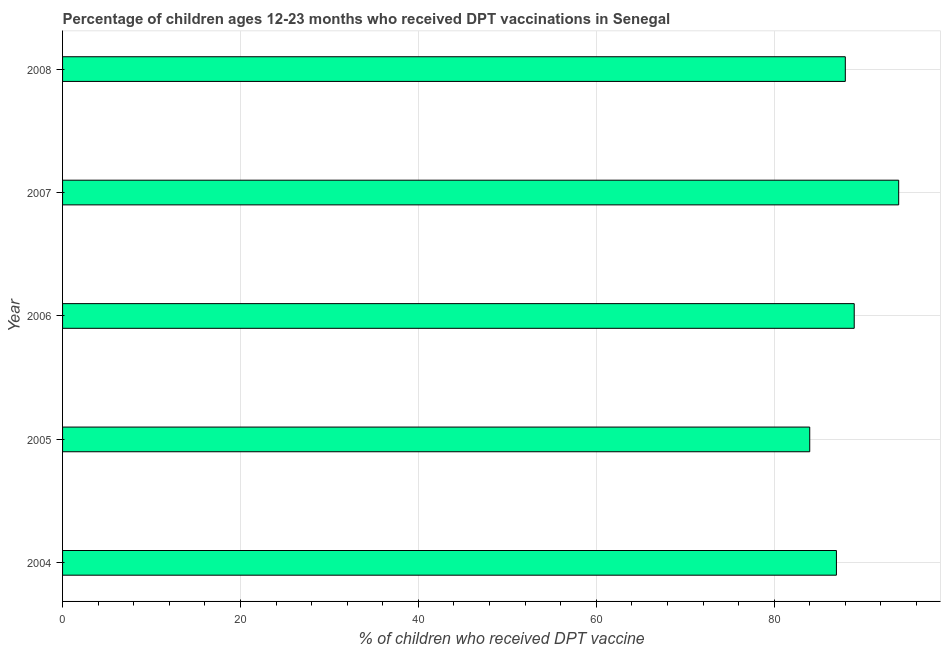Does the graph contain any zero values?
Ensure brevity in your answer.  No. What is the title of the graph?
Make the answer very short. Percentage of children ages 12-23 months who received DPT vaccinations in Senegal. What is the label or title of the X-axis?
Provide a short and direct response. % of children who received DPT vaccine. What is the label or title of the Y-axis?
Your response must be concise. Year. What is the percentage of children who received dpt vaccine in 2008?
Your answer should be compact. 88. Across all years, what is the maximum percentage of children who received dpt vaccine?
Provide a succinct answer. 94. Across all years, what is the minimum percentage of children who received dpt vaccine?
Your answer should be compact. 84. In which year was the percentage of children who received dpt vaccine maximum?
Your response must be concise. 2007. In which year was the percentage of children who received dpt vaccine minimum?
Provide a succinct answer. 2005. What is the sum of the percentage of children who received dpt vaccine?
Ensure brevity in your answer.  442. Do a majority of the years between 2008 and 2005 (inclusive) have percentage of children who received dpt vaccine greater than 32 %?
Ensure brevity in your answer.  Yes. What is the ratio of the percentage of children who received dpt vaccine in 2007 to that in 2008?
Provide a succinct answer. 1.07. Is the difference between the percentage of children who received dpt vaccine in 2005 and 2006 greater than the difference between any two years?
Offer a very short reply. No. What is the difference between the highest and the second highest percentage of children who received dpt vaccine?
Your response must be concise. 5. Is the sum of the percentage of children who received dpt vaccine in 2004 and 2005 greater than the maximum percentage of children who received dpt vaccine across all years?
Ensure brevity in your answer.  Yes. What is the difference between the highest and the lowest percentage of children who received dpt vaccine?
Keep it short and to the point. 10. In how many years, is the percentage of children who received dpt vaccine greater than the average percentage of children who received dpt vaccine taken over all years?
Offer a terse response. 2. How many bars are there?
Keep it short and to the point. 5. Are all the bars in the graph horizontal?
Your answer should be very brief. Yes. How many years are there in the graph?
Provide a short and direct response. 5. What is the difference between two consecutive major ticks on the X-axis?
Offer a terse response. 20. What is the % of children who received DPT vaccine of 2006?
Your response must be concise. 89. What is the % of children who received DPT vaccine in 2007?
Provide a short and direct response. 94. What is the difference between the % of children who received DPT vaccine in 2004 and 2006?
Provide a succinct answer. -2. What is the difference between the % of children who received DPT vaccine in 2004 and 2007?
Provide a short and direct response. -7. What is the difference between the % of children who received DPT vaccine in 2005 and 2006?
Make the answer very short. -5. What is the difference between the % of children who received DPT vaccine in 2005 and 2007?
Your answer should be very brief. -10. What is the difference between the % of children who received DPT vaccine in 2005 and 2008?
Your answer should be compact. -4. What is the difference between the % of children who received DPT vaccine in 2006 and 2007?
Provide a succinct answer. -5. What is the ratio of the % of children who received DPT vaccine in 2004 to that in 2005?
Ensure brevity in your answer.  1.04. What is the ratio of the % of children who received DPT vaccine in 2004 to that in 2006?
Make the answer very short. 0.98. What is the ratio of the % of children who received DPT vaccine in 2004 to that in 2007?
Your response must be concise. 0.93. What is the ratio of the % of children who received DPT vaccine in 2004 to that in 2008?
Make the answer very short. 0.99. What is the ratio of the % of children who received DPT vaccine in 2005 to that in 2006?
Give a very brief answer. 0.94. What is the ratio of the % of children who received DPT vaccine in 2005 to that in 2007?
Your answer should be compact. 0.89. What is the ratio of the % of children who received DPT vaccine in 2005 to that in 2008?
Your answer should be very brief. 0.95. What is the ratio of the % of children who received DPT vaccine in 2006 to that in 2007?
Your answer should be very brief. 0.95. What is the ratio of the % of children who received DPT vaccine in 2007 to that in 2008?
Give a very brief answer. 1.07. 